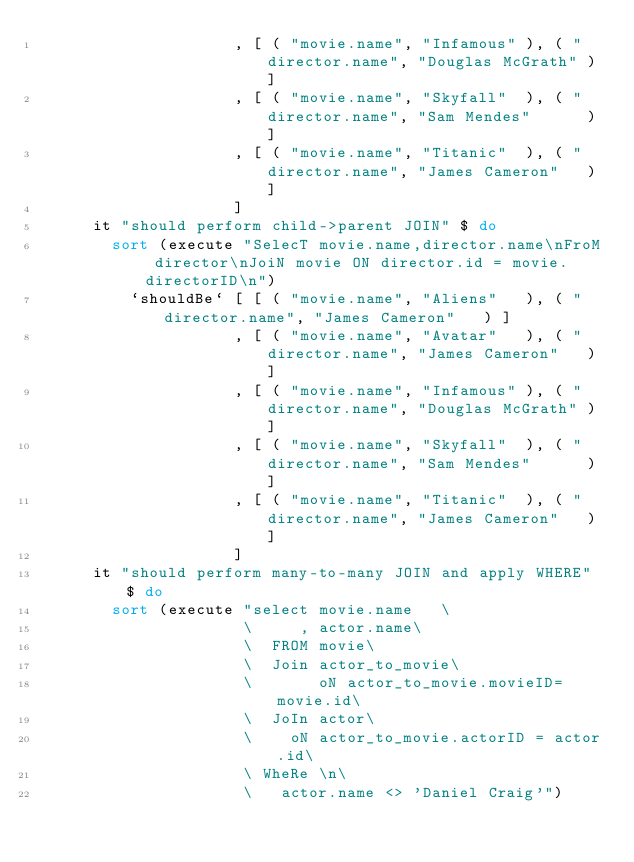Convert code to text. <code><loc_0><loc_0><loc_500><loc_500><_Haskell_>                     , [ ( "movie.name", "Infamous" ), ( "director.name", "Douglas McGrath" ) ]
                     , [ ( "movie.name", "Skyfall"  ), ( "director.name", "Sam Mendes"      ) ]
                     , [ ( "movie.name", "Titanic"  ), ( "director.name", "James Cameron"   ) ]
                     ]
      it "should perform child->parent JOIN" $ do
        sort (execute "SelecT movie.name,director.name\nFroM director\nJoiN movie ON director.id = movie.directorID\n")
          `shouldBe` [ [ ( "movie.name", "Aliens"   ), ( "director.name", "James Cameron"   ) ]
                     , [ ( "movie.name", "Avatar"   ), ( "director.name", "James Cameron"   ) ]
                     , [ ( "movie.name", "Infamous" ), ( "director.name", "Douglas McGrath" ) ]
                     , [ ( "movie.name", "Skyfall"  ), ( "director.name", "Sam Mendes"      ) ]
                     , [ ( "movie.name", "Titanic"  ), ( "director.name", "James Cameron"   ) ]
                     ]
      it "should perform many-to-many JOIN and apply WHERE" $ do
        sort (execute "select movie.name   \
                      \     , actor.name\
                      \  FROM movie\
                      \  Join actor_to_movie\
                      \       oN actor_to_movie.movieID=movie.id\
                      \  JoIn actor\
                      \    oN actor_to_movie.actorID = actor.id\
                      \ WheRe \n\
                      \   actor.name <> 'Daniel Craig'")</code> 